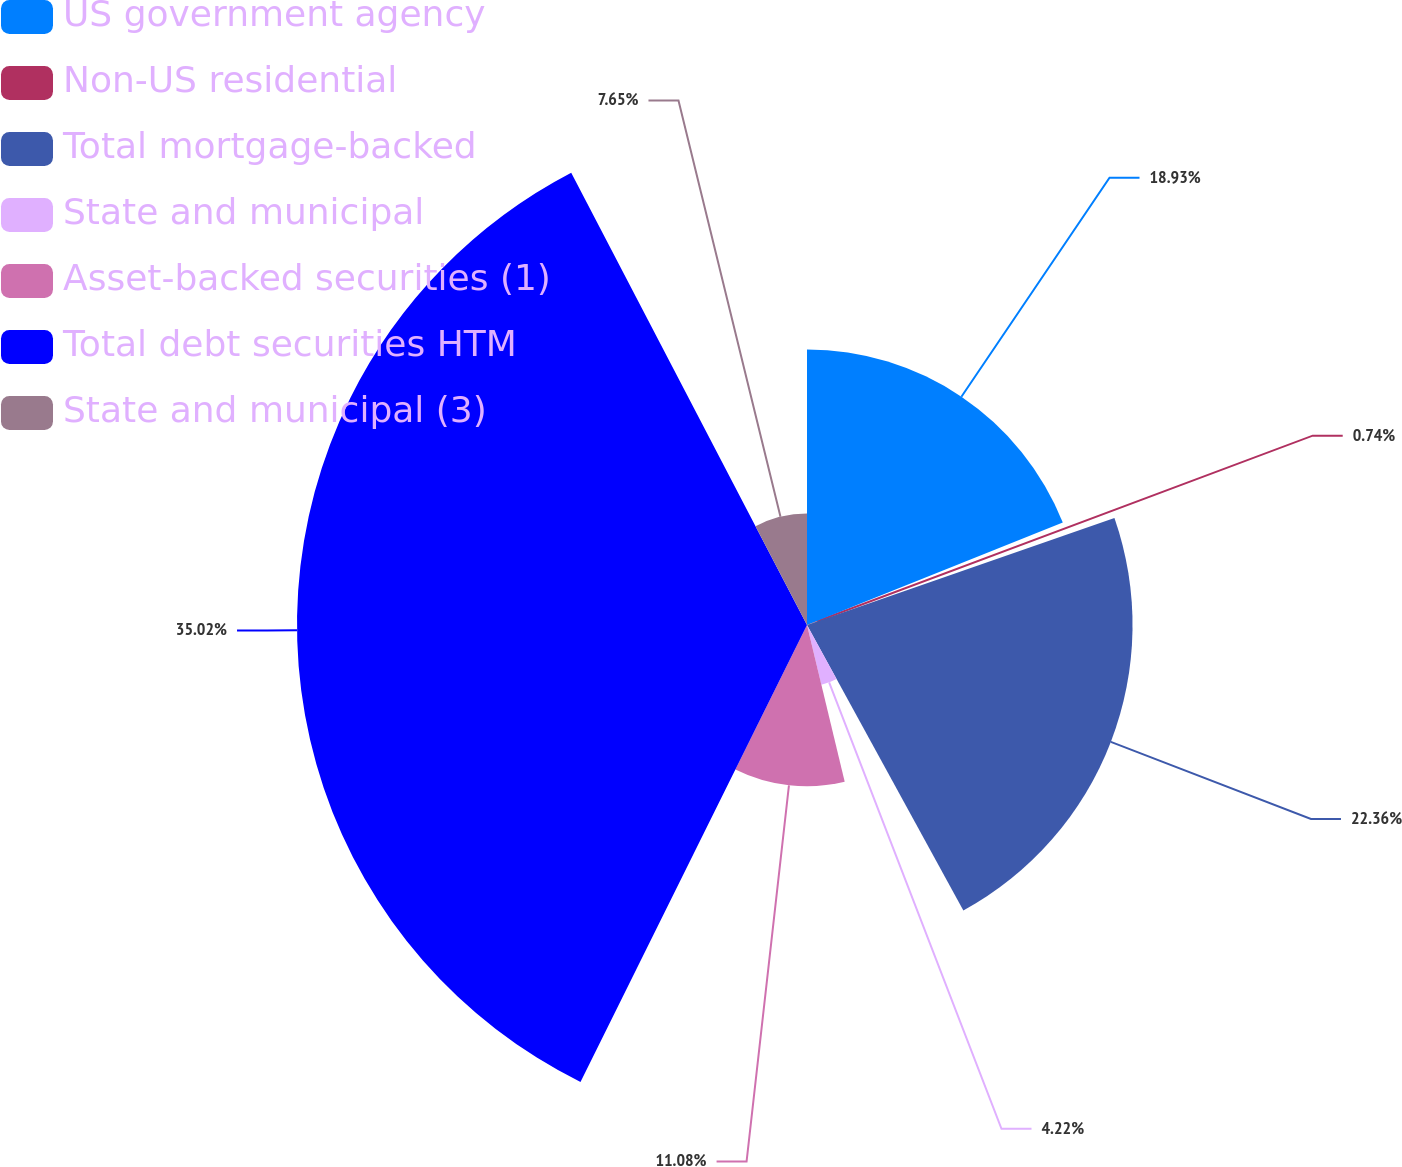<chart> <loc_0><loc_0><loc_500><loc_500><pie_chart><fcel>US government agency<fcel>Non-US residential<fcel>Total mortgage-backed<fcel>State and municipal<fcel>Asset-backed securities (1)<fcel>Total debt securities HTM<fcel>State and municipal (3)<nl><fcel>18.93%<fcel>0.74%<fcel>22.36%<fcel>4.22%<fcel>11.08%<fcel>35.03%<fcel>7.65%<nl></chart> 